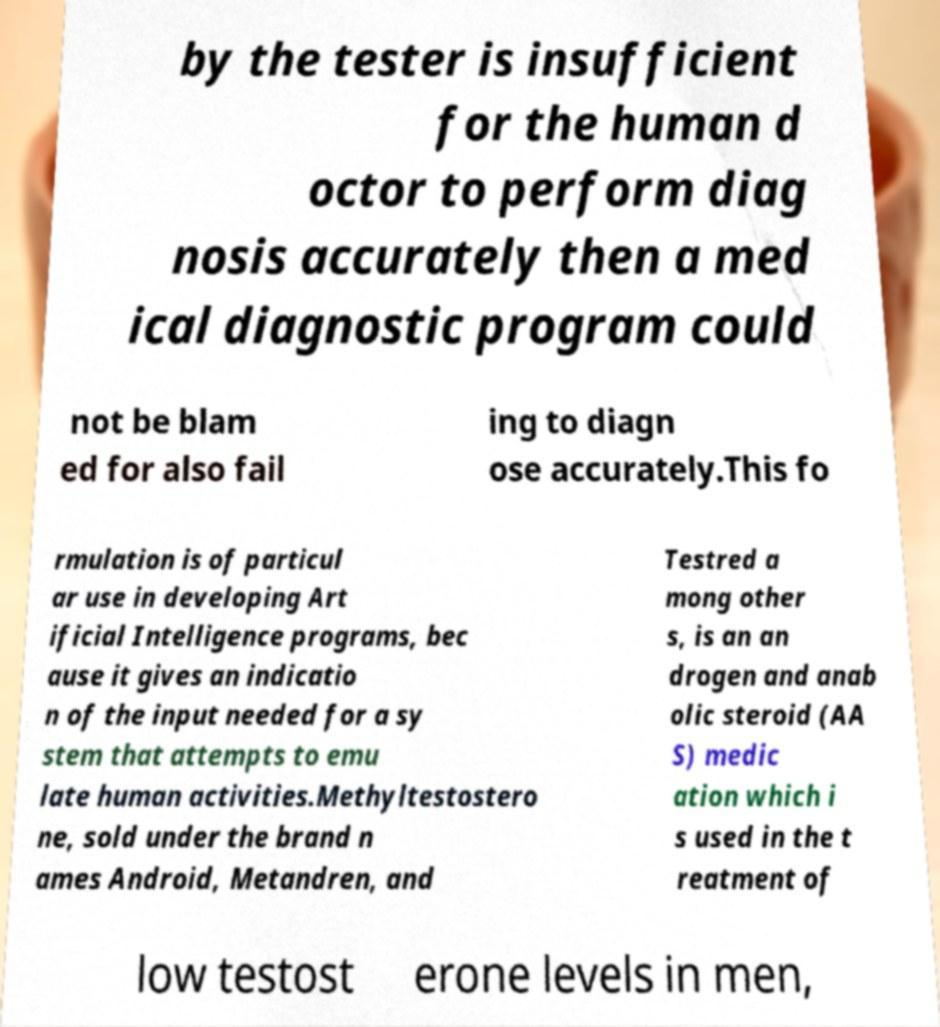Please read and relay the text visible in this image. What does it say? by the tester is insufficient for the human d octor to perform diag nosis accurately then a med ical diagnostic program could not be blam ed for also fail ing to diagn ose accurately.This fo rmulation is of particul ar use in developing Art ificial Intelligence programs, bec ause it gives an indicatio n of the input needed for a sy stem that attempts to emu late human activities.Methyltestostero ne, sold under the brand n ames Android, Metandren, and Testred a mong other s, is an an drogen and anab olic steroid (AA S) medic ation which i s used in the t reatment of low testost erone levels in men, 